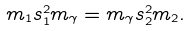Convert formula to latex. <formula><loc_0><loc_0><loc_500><loc_500>m _ { 1 } s _ { 1 } ^ { 2 } m _ { \gamma } = m _ { \gamma } s _ { 2 } ^ { 2 } m _ { 2 } .</formula> 